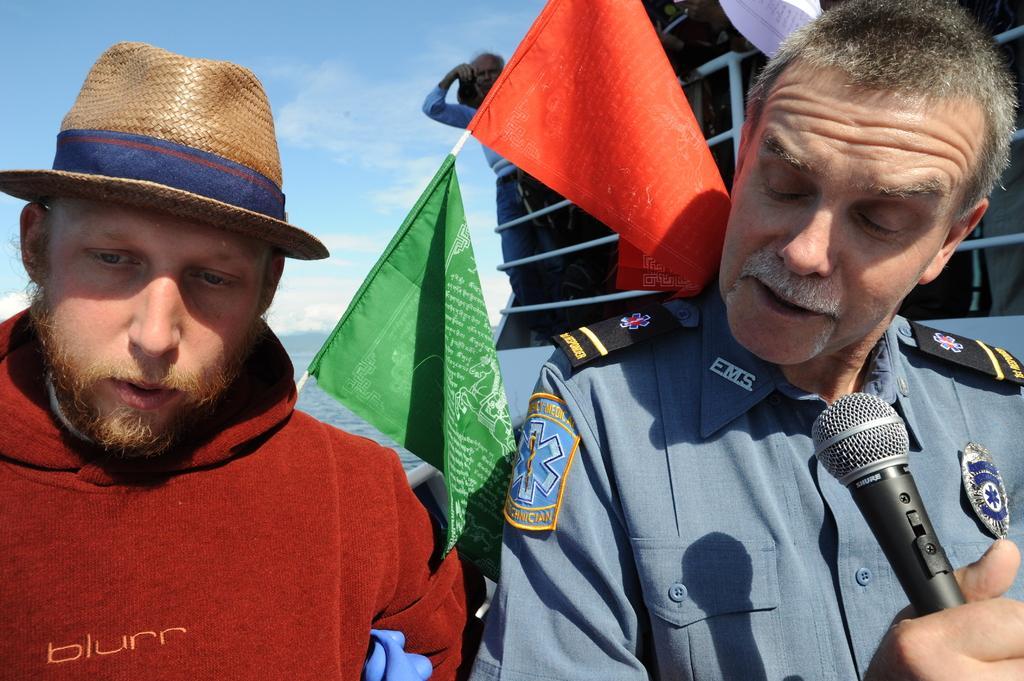Please provide a concise description of this image. In the image we can see there are two men who are standing and a man is wearing a cap and another man is holding a mic in his hand and at the back another man is carrying a camera in his hand. 